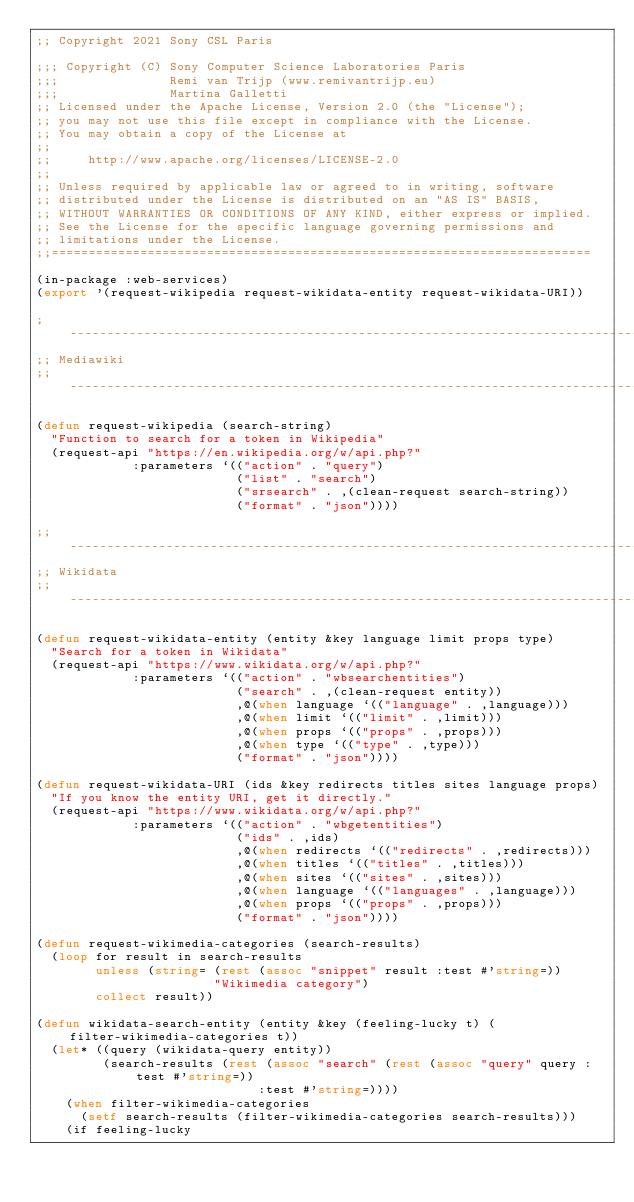<code> <loc_0><loc_0><loc_500><loc_500><_Lisp_>;; Copyright 2021 Sony CSL Paris

;;; Copyright (C) Sony Computer Science Laboratories Paris
;;;               Remi van Trijp (www.remivantrijp.eu)
;;;               Martina Galletti
;; Licensed under the Apache License, Version 2.0 (the "License");
;; you may not use this file except in compliance with the License.
;; You may obtain a copy of the License at
;;
;;     http://www.apache.org/licenses/LICENSE-2.0
;;
;; Unless required by applicable law or agreed to in writing, software
;; distributed under the License is distributed on an "AS IS" BASIS,
;; WITHOUT WARRANTIES OR CONDITIONS OF ANY KIND, either express or implied.
;; See the License for the specific language governing permissions and
;; limitations under the License.
;;=========================================================================

(in-package :web-services)
(export '(request-wikipedia request-wikidata-entity request-wikidata-URI))

; -----------------------------------------------------------------------------------------------------------
;; Mediawiki
;; -----------------------------------------------------------------------------------------------------------

(defun request-wikipedia (search-string)
  "Function to search for a token in Wikipedia"
  (request-api "https://en.wikipedia.org/w/api.php?"
             :parameters `(("action" . "query")
                           ("list" . "search")
                           ("srsearch" . ,(clean-request search-string))
                           ("format" . "json"))))

;; -----------------------------------------------------------------------------------------------------------
;; Wikidata
;; -----------------------------------------------------------------------------------------------------------

(defun request-wikidata-entity (entity &key language limit props type)
  "Search for a token in Wikidata"
  (request-api "https://www.wikidata.org/w/api.php?"
             :parameters `(("action" . "wbsearchentities")
                           ("search" . ,(clean-request entity))
                           ,@(when language `(("language" . ,language)))
                           ,@(when limit `(("limit" . ,limit)))
                           ,@(when props `(("props" . ,props)))
                           ,@(when type `(("type" . ,type)))
                           ("format" . "json"))))

(defun request-wikidata-URI (ids &key redirects titles sites language props)
  "If you know the entity URI, get it directly."
  (request-api "https://www.wikidata.org/w/api.php?"
             :parameters `(("action" . "wbgetentities")
                           ("ids" . ,ids)
                           ,@(when redirects `(("redirects" . ,redirects)))
                           ,@(when titles `(("titles" . ,titles)))
                           ,@(when sites `(("sites" . ,sites)))
                           ,@(when language `(("languages" . ,language)))
                           ,@(when props `(("props" . ,props)))
                           ("format" . "json"))))

(defun request-wikimedia-categories (search-results)
  (loop for result in search-results
        unless (string= (rest (assoc "snippet" result :test #'string=))
                        "Wikimedia category")
        collect result))

(defun wikidata-search-entity (entity &key (feeling-lucky t) (filter-wikimedia-categories t))
  (let* ((query (wikidata-query entity))
         (search-results (rest (assoc "search" (rest (assoc "query" query :test #'string=))
                              :test #'string=))))
    (when filter-wikimedia-categories
      (setf search-results (filter-wikimedia-categories search-results)))
    (if feeling-lucky</code> 